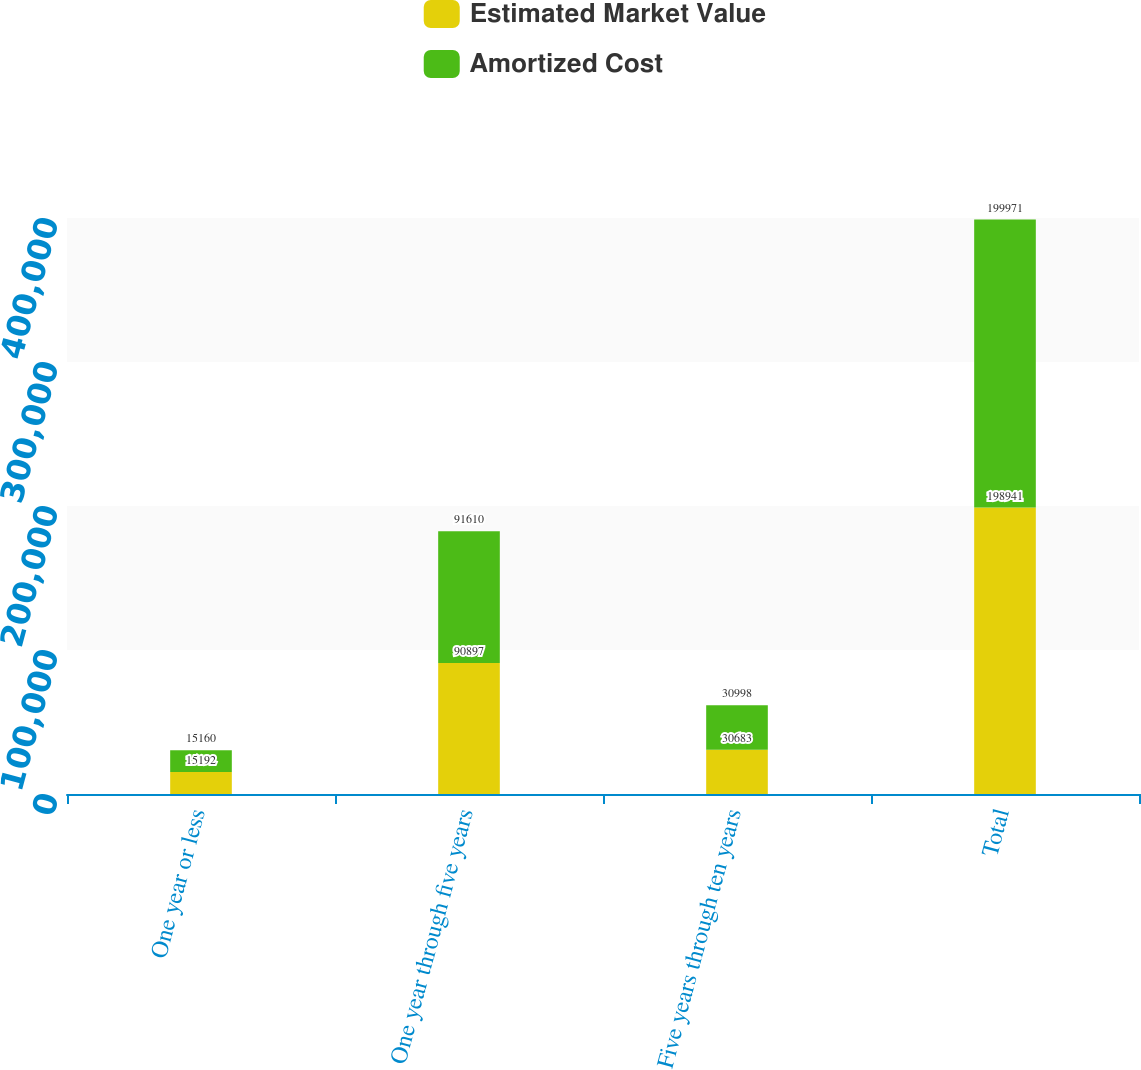Convert chart. <chart><loc_0><loc_0><loc_500><loc_500><stacked_bar_chart><ecel><fcel>One year or less<fcel>One year through five years<fcel>Five years through ten years<fcel>Total<nl><fcel>Estimated Market Value<fcel>15192<fcel>90897<fcel>30683<fcel>198941<nl><fcel>Amortized Cost<fcel>15160<fcel>91610<fcel>30998<fcel>199971<nl></chart> 